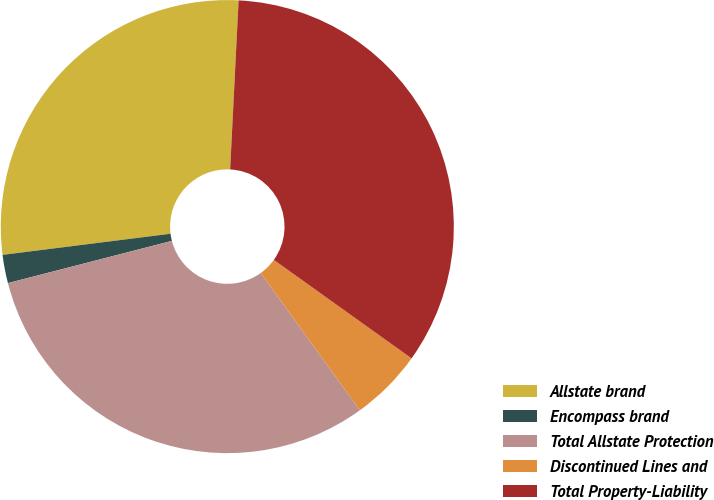<chart> <loc_0><loc_0><loc_500><loc_500><pie_chart><fcel>Allstate brand<fcel>Encompass brand<fcel>Total Allstate Protection<fcel>Discontinued Lines and<fcel>Total Property-Liability<nl><fcel>27.79%<fcel>2.02%<fcel>30.94%<fcel>5.17%<fcel>34.09%<nl></chart> 